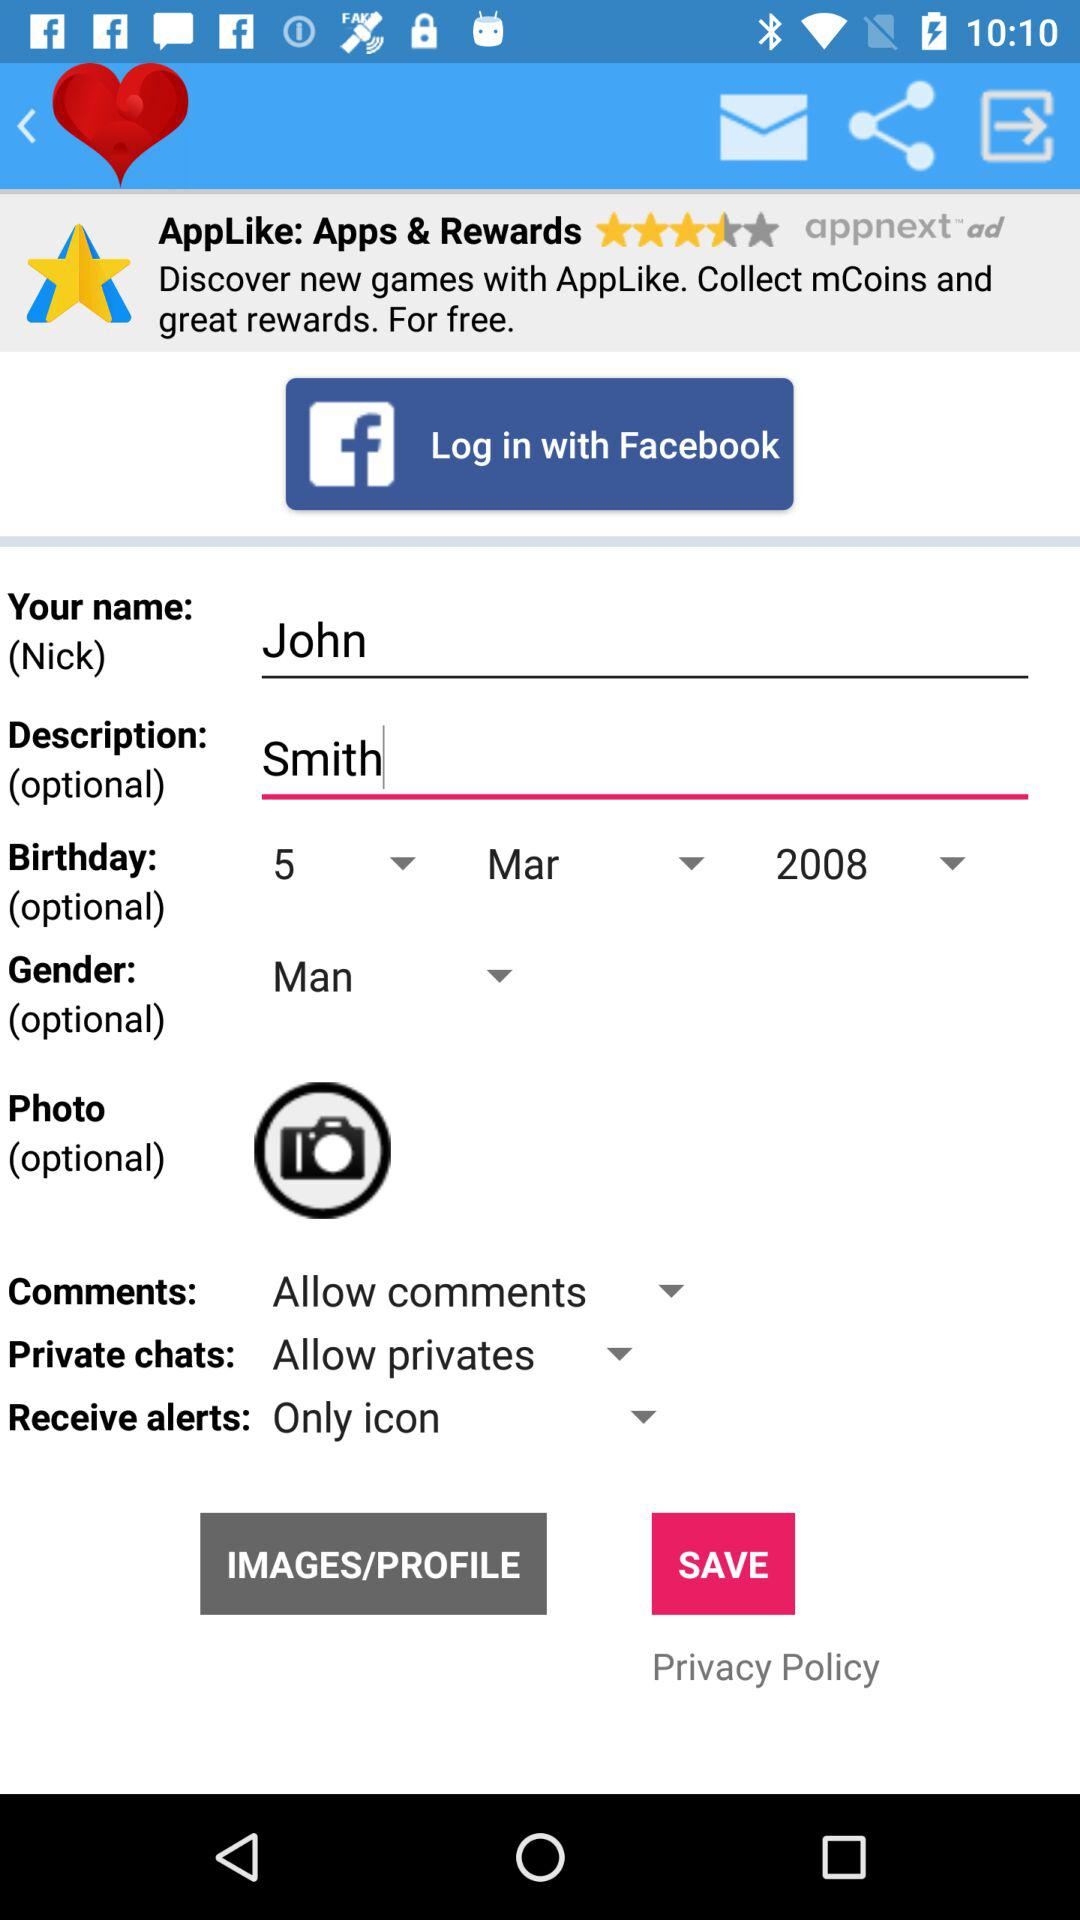What is the gender? The gender is "Man". 